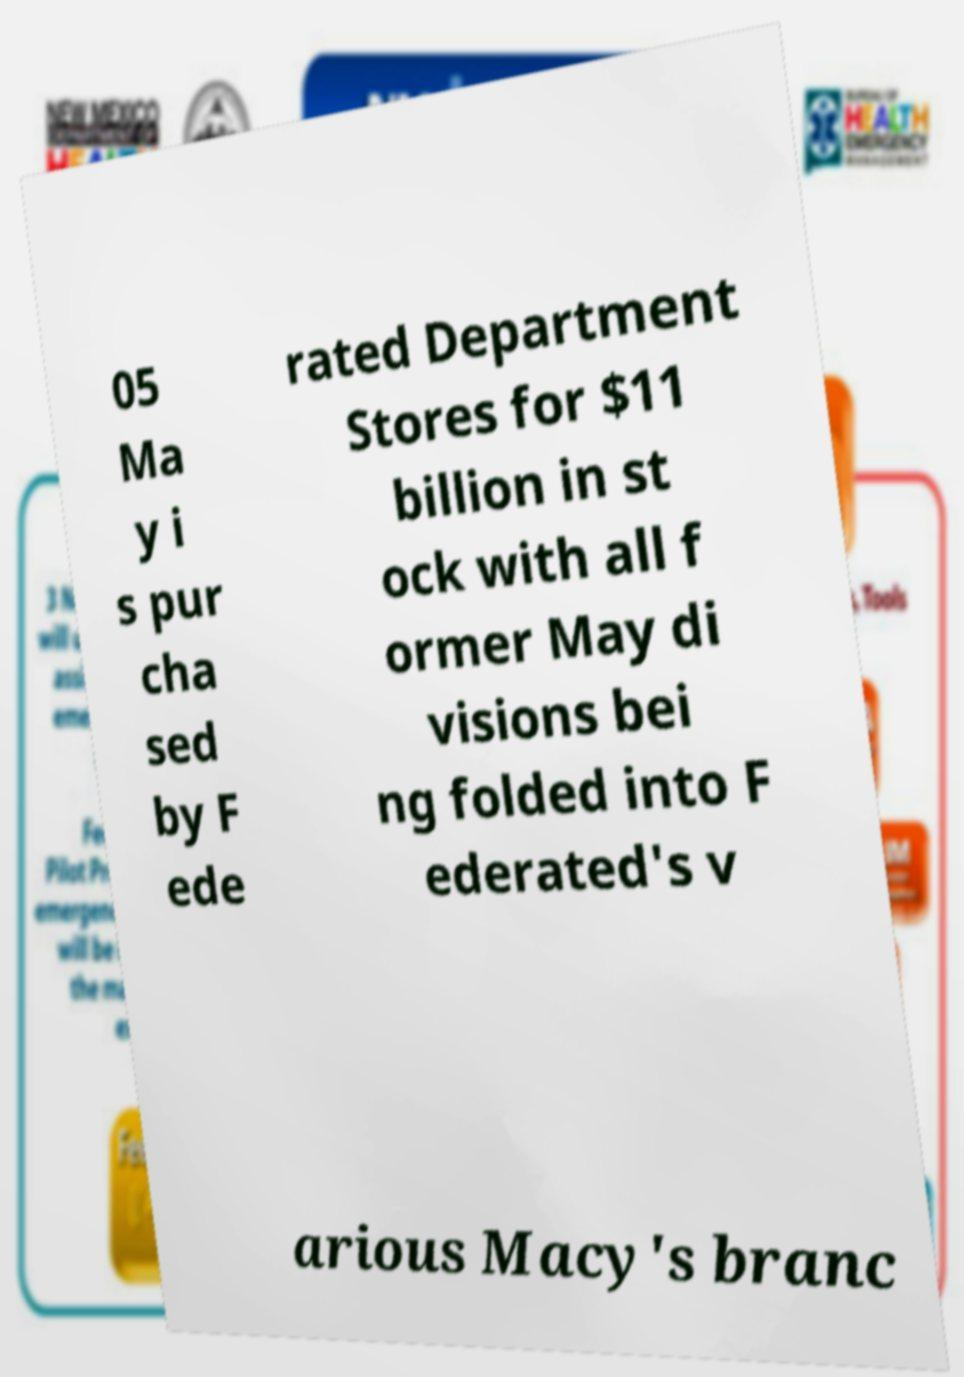There's text embedded in this image that I need extracted. Can you transcribe it verbatim? 05 Ma y i s pur cha sed by F ede rated Department Stores for $11 billion in st ock with all f ormer May di visions bei ng folded into F ederated's v arious Macy's branc 